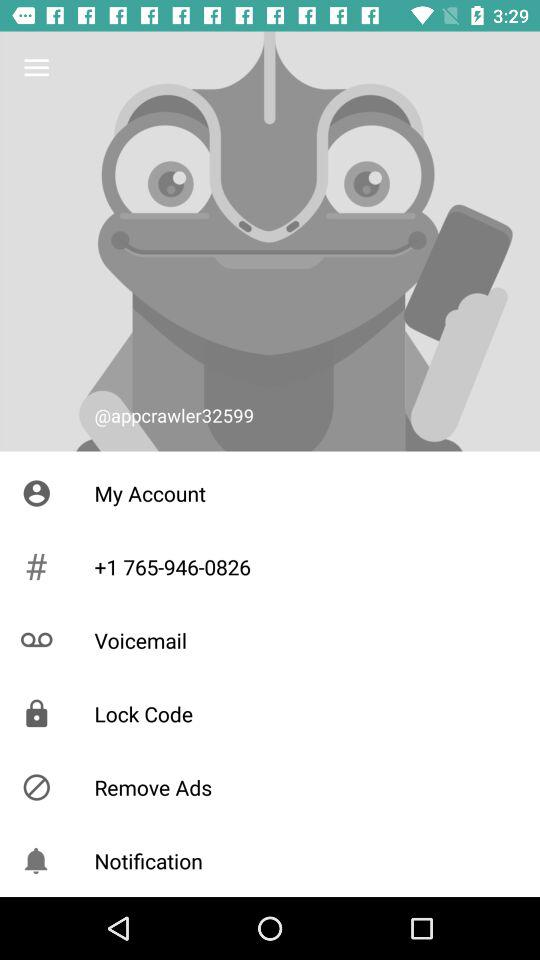What is the shown contact number? The shown contact number is +1 765-946-0826. 